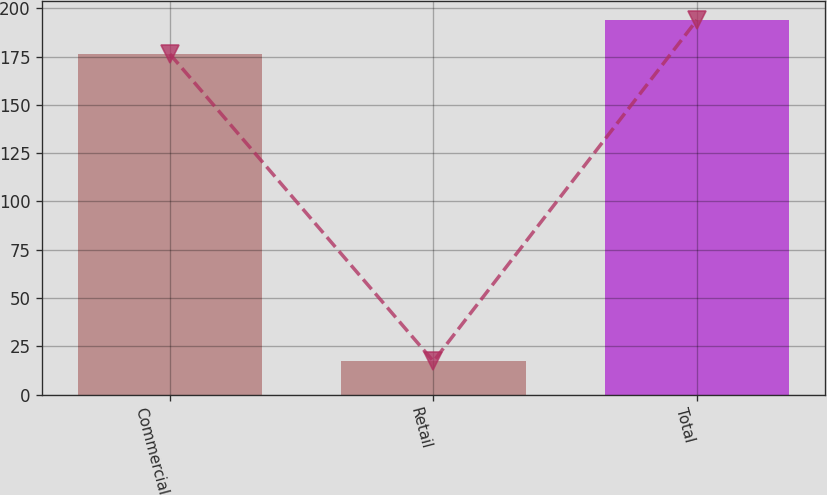Convert chart to OTSL. <chart><loc_0><loc_0><loc_500><loc_500><bar_chart><fcel>Commercial<fcel>Retail<fcel>Total<nl><fcel>176.3<fcel>17.2<fcel>193.93<nl></chart> 